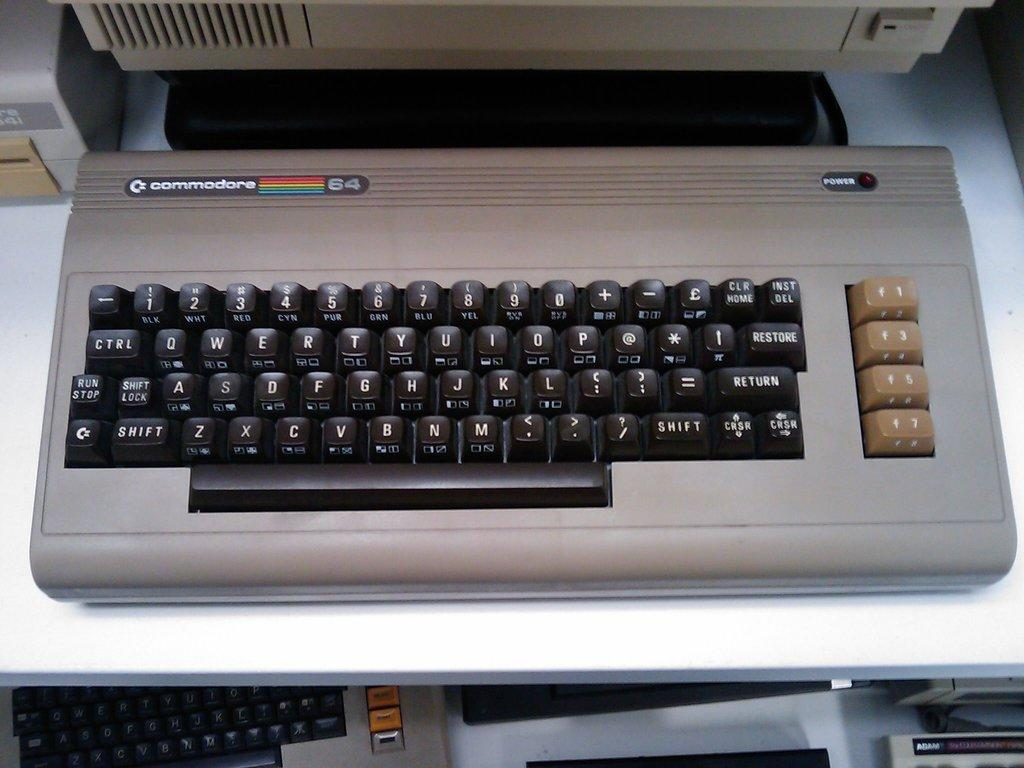<image>
Share a concise interpretation of the image provided. A Commodore computer keyboard sitting on a desk. 